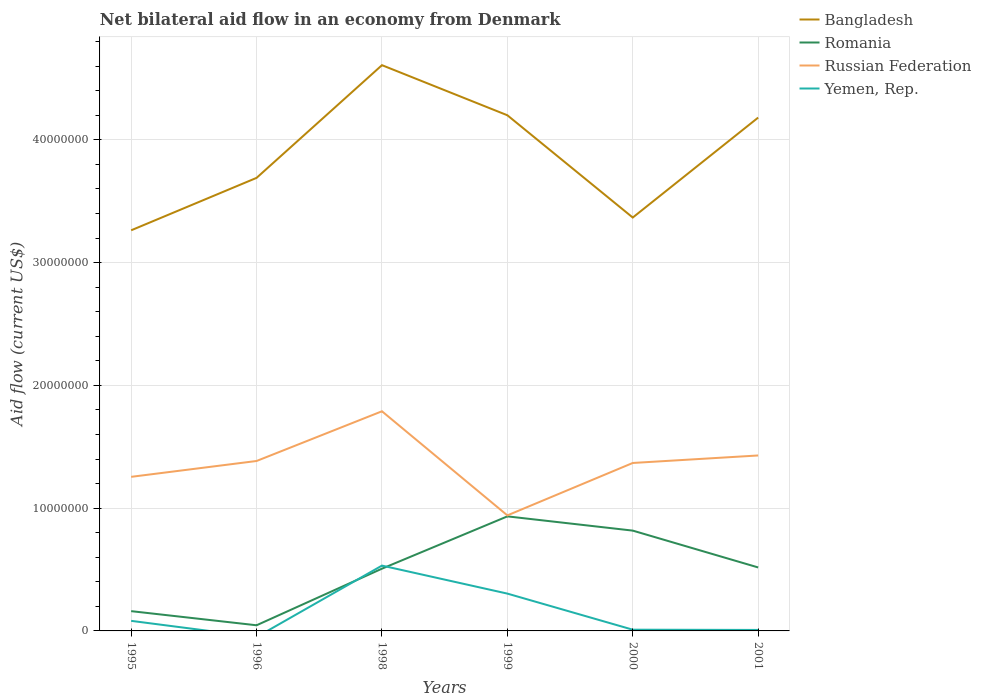How many different coloured lines are there?
Provide a succinct answer. 4. Across all years, what is the maximum net bilateral aid flow in Russian Federation?
Ensure brevity in your answer.  9.41e+06. What is the total net bilateral aid flow in Romania in the graph?
Your answer should be very brief. -4.71e+06. What is the difference between the highest and the second highest net bilateral aid flow in Romania?
Give a very brief answer. 8.87e+06. How many lines are there?
Your response must be concise. 4. How many years are there in the graph?
Your answer should be compact. 6. What is the difference between two consecutive major ticks on the Y-axis?
Provide a succinct answer. 1.00e+07. Are the values on the major ticks of Y-axis written in scientific E-notation?
Offer a very short reply. No. Does the graph contain any zero values?
Offer a very short reply. Yes. Does the graph contain grids?
Offer a very short reply. Yes. Where does the legend appear in the graph?
Keep it short and to the point. Top right. How many legend labels are there?
Your answer should be very brief. 4. How are the legend labels stacked?
Ensure brevity in your answer.  Vertical. What is the title of the graph?
Your answer should be very brief. Net bilateral aid flow in an economy from Denmark. What is the label or title of the Y-axis?
Keep it short and to the point. Aid flow (current US$). What is the Aid flow (current US$) of Bangladesh in 1995?
Your answer should be compact. 3.26e+07. What is the Aid flow (current US$) of Romania in 1995?
Make the answer very short. 1.61e+06. What is the Aid flow (current US$) in Russian Federation in 1995?
Ensure brevity in your answer.  1.26e+07. What is the Aid flow (current US$) of Yemen, Rep. in 1995?
Give a very brief answer. 8.20e+05. What is the Aid flow (current US$) of Bangladesh in 1996?
Keep it short and to the point. 3.69e+07. What is the Aid flow (current US$) in Romania in 1996?
Offer a terse response. 4.60e+05. What is the Aid flow (current US$) of Russian Federation in 1996?
Your answer should be very brief. 1.38e+07. What is the Aid flow (current US$) of Yemen, Rep. in 1996?
Offer a terse response. 0. What is the Aid flow (current US$) of Bangladesh in 1998?
Make the answer very short. 4.61e+07. What is the Aid flow (current US$) of Romania in 1998?
Offer a very short reply. 5.07e+06. What is the Aid flow (current US$) of Russian Federation in 1998?
Make the answer very short. 1.79e+07. What is the Aid flow (current US$) in Yemen, Rep. in 1998?
Your answer should be compact. 5.32e+06. What is the Aid flow (current US$) of Bangladesh in 1999?
Ensure brevity in your answer.  4.20e+07. What is the Aid flow (current US$) in Romania in 1999?
Ensure brevity in your answer.  9.33e+06. What is the Aid flow (current US$) of Russian Federation in 1999?
Provide a succinct answer. 9.41e+06. What is the Aid flow (current US$) in Yemen, Rep. in 1999?
Provide a short and direct response. 3.04e+06. What is the Aid flow (current US$) in Bangladesh in 2000?
Your answer should be very brief. 3.37e+07. What is the Aid flow (current US$) in Romania in 2000?
Your answer should be compact. 8.17e+06. What is the Aid flow (current US$) of Russian Federation in 2000?
Provide a succinct answer. 1.37e+07. What is the Aid flow (current US$) of Yemen, Rep. in 2000?
Provide a short and direct response. 1.00e+05. What is the Aid flow (current US$) in Bangladesh in 2001?
Give a very brief answer. 4.18e+07. What is the Aid flow (current US$) of Romania in 2001?
Provide a short and direct response. 5.17e+06. What is the Aid flow (current US$) in Russian Federation in 2001?
Your answer should be very brief. 1.43e+07. Across all years, what is the maximum Aid flow (current US$) of Bangladesh?
Your answer should be compact. 4.61e+07. Across all years, what is the maximum Aid flow (current US$) in Romania?
Offer a very short reply. 9.33e+06. Across all years, what is the maximum Aid flow (current US$) of Russian Federation?
Ensure brevity in your answer.  1.79e+07. Across all years, what is the maximum Aid flow (current US$) of Yemen, Rep.?
Offer a very short reply. 5.32e+06. Across all years, what is the minimum Aid flow (current US$) of Bangladesh?
Your answer should be compact. 3.26e+07. Across all years, what is the minimum Aid flow (current US$) in Russian Federation?
Your response must be concise. 9.41e+06. What is the total Aid flow (current US$) of Bangladesh in the graph?
Provide a short and direct response. 2.33e+08. What is the total Aid flow (current US$) of Romania in the graph?
Your response must be concise. 2.98e+07. What is the total Aid flow (current US$) in Russian Federation in the graph?
Your answer should be very brief. 8.17e+07. What is the total Aid flow (current US$) in Yemen, Rep. in the graph?
Your answer should be compact. 9.36e+06. What is the difference between the Aid flow (current US$) in Bangladesh in 1995 and that in 1996?
Keep it short and to the point. -4.27e+06. What is the difference between the Aid flow (current US$) of Romania in 1995 and that in 1996?
Your response must be concise. 1.15e+06. What is the difference between the Aid flow (current US$) of Russian Federation in 1995 and that in 1996?
Keep it short and to the point. -1.29e+06. What is the difference between the Aid flow (current US$) in Bangladesh in 1995 and that in 1998?
Offer a terse response. -1.34e+07. What is the difference between the Aid flow (current US$) of Romania in 1995 and that in 1998?
Provide a short and direct response. -3.46e+06. What is the difference between the Aid flow (current US$) of Russian Federation in 1995 and that in 1998?
Make the answer very short. -5.34e+06. What is the difference between the Aid flow (current US$) of Yemen, Rep. in 1995 and that in 1998?
Make the answer very short. -4.50e+06. What is the difference between the Aid flow (current US$) of Bangladesh in 1995 and that in 1999?
Give a very brief answer. -9.37e+06. What is the difference between the Aid flow (current US$) of Romania in 1995 and that in 1999?
Provide a succinct answer. -7.72e+06. What is the difference between the Aid flow (current US$) in Russian Federation in 1995 and that in 1999?
Keep it short and to the point. 3.14e+06. What is the difference between the Aid flow (current US$) of Yemen, Rep. in 1995 and that in 1999?
Offer a terse response. -2.22e+06. What is the difference between the Aid flow (current US$) of Bangladesh in 1995 and that in 2000?
Ensure brevity in your answer.  -1.04e+06. What is the difference between the Aid flow (current US$) of Romania in 1995 and that in 2000?
Your response must be concise. -6.56e+06. What is the difference between the Aid flow (current US$) of Russian Federation in 1995 and that in 2000?
Give a very brief answer. -1.13e+06. What is the difference between the Aid flow (current US$) in Yemen, Rep. in 1995 and that in 2000?
Your answer should be very brief. 7.20e+05. What is the difference between the Aid flow (current US$) in Bangladesh in 1995 and that in 2001?
Your response must be concise. -9.18e+06. What is the difference between the Aid flow (current US$) of Romania in 1995 and that in 2001?
Give a very brief answer. -3.56e+06. What is the difference between the Aid flow (current US$) in Russian Federation in 1995 and that in 2001?
Make the answer very short. -1.74e+06. What is the difference between the Aid flow (current US$) in Yemen, Rep. in 1995 and that in 2001?
Offer a very short reply. 7.40e+05. What is the difference between the Aid flow (current US$) of Bangladesh in 1996 and that in 1998?
Give a very brief answer. -9.18e+06. What is the difference between the Aid flow (current US$) in Romania in 1996 and that in 1998?
Your response must be concise. -4.61e+06. What is the difference between the Aid flow (current US$) of Russian Federation in 1996 and that in 1998?
Your response must be concise. -4.05e+06. What is the difference between the Aid flow (current US$) in Bangladesh in 1996 and that in 1999?
Keep it short and to the point. -5.10e+06. What is the difference between the Aid flow (current US$) of Romania in 1996 and that in 1999?
Provide a short and direct response. -8.87e+06. What is the difference between the Aid flow (current US$) of Russian Federation in 1996 and that in 1999?
Keep it short and to the point. 4.43e+06. What is the difference between the Aid flow (current US$) of Bangladesh in 1996 and that in 2000?
Make the answer very short. 3.23e+06. What is the difference between the Aid flow (current US$) in Romania in 1996 and that in 2000?
Keep it short and to the point. -7.71e+06. What is the difference between the Aid flow (current US$) of Russian Federation in 1996 and that in 2000?
Give a very brief answer. 1.60e+05. What is the difference between the Aid flow (current US$) in Bangladesh in 1996 and that in 2001?
Give a very brief answer. -4.91e+06. What is the difference between the Aid flow (current US$) of Romania in 1996 and that in 2001?
Make the answer very short. -4.71e+06. What is the difference between the Aid flow (current US$) of Russian Federation in 1996 and that in 2001?
Offer a very short reply. -4.50e+05. What is the difference between the Aid flow (current US$) in Bangladesh in 1998 and that in 1999?
Ensure brevity in your answer.  4.08e+06. What is the difference between the Aid flow (current US$) in Romania in 1998 and that in 1999?
Provide a short and direct response. -4.26e+06. What is the difference between the Aid flow (current US$) of Russian Federation in 1998 and that in 1999?
Offer a terse response. 8.48e+06. What is the difference between the Aid flow (current US$) in Yemen, Rep. in 1998 and that in 1999?
Make the answer very short. 2.28e+06. What is the difference between the Aid flow (current US$) of Bangladesh in 1998 and that in 2000?
Keep it short and to the point. 1.24e+07. What is the difference between the Aid flow (current US$) in Romania in 1998 and that in 2000?
Provide a short and direct response. -3.10e+06. What is the difference between the Aid flow (current US$) in Russian Federation in 1998 and that in 2000?
Provide a succinct answer. 4.21e+06. What is the difference between the Aid flow (current US$) in Yemen, Rep. in 1998 and that in 2000?
Your answer should be compact. 5.22e+06. What is the difference between the Aid flow (current US$) of Bangladesh in 1998 and that in 2001?
Your response must be concise. 4.27e+06. What is the difference between the Aid flow (current US$) of Romania in 1998 and that in 2001?
Your response must be concise. -1.00e+05. What is the difference between the Aid flow (current US$) in Russian Federation in 1998 and that in 2001?
Provide a succinct answer. 3.60e+06. What is the difference between the Aid flow (current US$) of Yemen, Rep. in 1998 and that in 2001?
Provide a succinct answer. 5.24e+06. What is the difference between the Aid flow (current US$) in Bangladesh in 1999 and that in 2000?
Provide a short and direct response. 8.33e+06. What is the difference between the Aid flow (current US$) in Romania in 1999 and that in 2000?
Provide a short and direct response. 1.16e+06. What is the difference between the Aid flow (current US$) of Russian Federation in 1999 and that in 2000?
Your answer should be compact. -4.27e+06. What is the difference between the Aid flow (current US$) of Yemen, Rep. in 1999 and that in 2000?
Make the answer very short. 2.94e+06. What is the difference between the Aid flow (current US$) in Romania in 1999 and that in 2001?
Your response must be concise. 4.16e+06. What is the difference between the Aid flow (current US$) in Russian Federation in 1999 and that in 2001?
Keep it short and to the point. -4.88e+06. What is the difference between the Aid flow (current US$) in Yemen, Rep. in 1999 and that in 2001?
Your answer should be very brief. 2.96e+06. What is the difference between the Aid flow (current US$) of Bangladesh in 2000 and that in 2001?
Keep it short and to the point. -8.14e+06. What is the difference between the Aid flow (current US$) of Russian Federation in 2000 and that in 2001?
Offer a terse response. -6.10e+05. What is the difference between the Aid flow (current US$) of Bangladesh in 1995 and the Aid flow (current US$) of Romania in 1996?
Your response must be concise. 3.22e+07. What is the difference between the Aid flow (current US$) of Bangladesh in 1995 and the Aid flow (current US$) of Russian Federation in 1996?
Your response must be concise. 1.88e+07. What is the difference between the Aid flow (current US$) in Romania in 1995 and the Aid flow (current US$) in Russian Federation in 1996?
Offer a terse response. -1.22e+07. What is the difference between the Aid flow (current US$) in Bangladesh in 1995 and the Aid flow (current US$) in Romania in 1998?
Keep it short and to the point. 2.76e+07. What is the difference between the Aid flow (current US$) of Bangladesh in 1995 and the Aid flow (current US$) of Russian Federation in 1998?
Offer a terse response. 1.47e+07. What is the difference between the Aid flow (current US$) of Bangladesh in 1995 and the Aid flow (current US$) of Yemen, Rep. in 1998?
Provide a succinct answer. 2.73e+07. What is the difference between the Aid flow (current US$) of Romania in 1995 and the Aid flow (current US$) of Russian Federation in 1998?
Offer a terse response. -1.63e+07. What is the difference between the Aid flow (current US$) of Romania in 1995 and the Aid flow (current US$) of Yemen, Rep. in 1998?
Offer a terse response. -3.71e+06. What is the difference between the Aid flow (current US$) in Russian Federation in 1995 and the Aid flow (current US$) in Yemen, Rep. in 1998?
Provide a succinct answer. 7.23e+06. What is the difference between the Aid flow (current US$) in Bangladesh in 1995 and the Aid flow (current US$) in Romania in 1999?
Provide a short and direct response. 2.33e+07. What is the difference between the Aid flow (current US$) in Bangladesh in 1995 and the Aid flow (current US$) in Russian Federation in 1999?
Offer a terse response. 2.32e+07. What is the difference between the Aid flow (current US$) of Bangladesh in 1995 and the Aid flow (current US$) of Yemen, Rep. in 1999?
Provide a short and direct response. 2.96e+07. What is the difference between the Aid flow (current US$) in Romania in 1995 and the Aid flow (current US$) in Russian Federation in 1999?
Your response must be concise. -7.80e+06. What is the difference between the Aid flow (current US$) of Romania in 1995 and the Aid flow (current US$) of Yemen, Rep. in 1999?
Give a very brief answer. -1.43e+06. What is the difference between the Aid flow (current US$) in Russian Federation in 1995 and the Aid flow (current US$) in Yemen, Rep. in 1999?
Provide a succinct answer. 9.51e+06. What is the difference between the Aid flow (current US$) in Bangladesh in 1995 and the Aid flow (current US$) in Romania in 2000?
Provide a short and direct response. 2.45e+07. What is the difference between the Aid flow (current US$) of Bangladesh in 1995 and the Aid flow (current US$) of Russian Federation in 2000?
Provide a short and direct response. 1.90e+07. What is the difference between the Aid flow (current US$) in Bangladesh in 1995 and the Aid flow (current US$) in Yemen, Rep. in 2000?
Keep it short and to the point. 3.25e+07. What is the difference between the Aid flow (current US$) in Romania in 1995 and the Aid flow (current US$) in Russian Federation in 2000?
Offer a terse response. -1.21e+07. What is the difference between the Aid flow (current US$) in Romania in 1995 and the Aid flow (current US$) in Yemen, Rep. in 2000?
Make the answer very short. 1.51e+06. What is the difference between the Aid flow (current US$) in Russian Federation in 1995 and the Aid flow (current US$) in Yemen, Rep. in 2000?
Keep it short and to the point. 1.24e+07. What is the difference between the Aid flow (current US$) of Bangladesh in 1995 and the Aid flow (current US$) of Romania in 2001?
Make the answer very short. 2.75e+07. What is the difference between the Aid flow (current US$) of Bangladesh in 1995 and the Aid flow (current US$) of Russian Federation in 2001?
Ensure brevity in your answer.  1.83e+07. What is the difference between the Aid flow (current US$) of Bangladesh in 1995 and the Aid flow (current US$) of Yemen, Rep. in 2001?
Provide a succinct answer. 3.26e+07. What is the difference between the Aid flow (current US$) in Romania in 1995 and the Aid flow (current US$) in Russian Federation in 2001?
Your answer should be compact. -1.27e+07. What is the difference between the Aid flow (current US$) of Romania in 1995 and the Aid flow (current US$) of Yemen, Rep. in 2001?
Keep it short and to the point. 1.53e+06. What is the difference between the Aid flow (current US$) in Russian Federation in 1995 and the Aid flow (current US$) in Yemen, Rep. in 2001?
Provide a short and direct response. 1.25e+07. What is the difference between the Aid flow (current US$) of Bangladesh in 1996 and the Aid flow (current US$) of Romania in 1998?
Keep it short and to the point. 3.18e+07. What is the difference between the Aid flow (current US$) of Bangladesh in 1996 and the Aid flow (current US$) of Russian Federation in 1998?
Provide a short and direct response. 1.90e+07. What is the difference between the Aid flow (current US$) of Bangladesh in 1996 and the Aid flow (current US$) of Yemen, Rep. in 1998?
Provide a succinct answer. 3.16e+07. What is the difference between the Aid flow (current US$) in Romania in 1996 and the Aid flow (current US$) in Russian Federation in 1998?
Your response must be concise. -1.74e+07. What is the difference between the Aid flow (current US$) in Romania in 1996 and the Aid flow (current US$) in Yemen, Rep. in 1998?
Ensure brevity in your answer.  -4.86e+06. What is the difference between the Aid flow (current US$) in Russian Federation in 1996 and the Aid flow (current US$) in Yemen, Rep. in 1998?
Offer a terse response. 8.52e+06. What is the difference between the Aid flow (current US$) in Bangladesh in 1996 and the Aid flow (current US$) in Romania in 1999?
Give a very brief answer. 2.76e+07. What is the difference between the Aid flow (current US$) of Bangladesh in 1996 and the Aid flow (current US$) of Russian Federation in 1999?
Your answer should be compact. 2.75e+07. What is the difference between the Aid flow (current US$) of Bangladesh in 1996 and the Aid flow (current US$) of Yemen, Rep. in 1999?
Make the answer very short. 3.39e+07. What is the difference between the Aid flow (current US$) in Romania in 1996 and the Aid flow (current US$) in Russian Federation in 1999?
Provide a short and direct response. -8.95e+06. What is the difference between the Aid flow (current US$) in Romania in 1996 and the Aid flow (current US$) in Yemen, Rep. in 1999?
Your response must be concise. -2.58e+06. What is the difference between the Aid flow (current US$) of Russian Federation in 1996 and the Aid flow (current US$) of Yemen, Rep. in 1999?
Give a very brief answer. 1.08e+07. What is the difference between the Aid flow (current US$) of Bangladesh in 1996 and the Aid flow (current US$) of Romania in 2000?
Provide a short and direct response. 2.87e+07. What is the difference between the Aid flow (current US$) of Bangladesh in 1996 and the Aid flow (current US$) of Russian Federation in 2000?
Make the answer very short. 2.32e+07. What is the difference between the Aid flow (current US$) in Bangladesh in 1996 and the Aid flow (current US$) in Yemen, Rep. in 2000?
Keep it short and to the point. 3.68e+07. What is the difference between the Aid flow (current US$) of Romania in 1996 and the Aid flow (current US$) of Russian Federation in 2000?
Your answer should be compact. -1.32e+07. What is the difference between the Aid flow (current US$) of Russian Federation in 1996 and the Aid flow (current US$) of Yemen, Rep. in 2000?
Provide a short and direct response. 1.37e+07. What is the difference between the Aid flow (current US$) of Bangladesh in 1996 and the Aid flow (current US$) of Romania in 2001?
Your answer should be compact. 3.17e+07. What is the difference between the Aid flow (current US$) of Bangladesh in 1996 and the Aid flow (current US$) of Russian Federation in 2001?
Offer a very short reply. 2.26e+07. What is the difference between the Aid flow (current US$) in Bangladesh in 1996 and the Aid flow (current US$) in Yemen, Rep. in 2001?
Your answer should be compact. 3.68e+07. What is the difference between the Aid flow (current US$) in Romania in 1996 and the Aid flow (current US$) in Russian Federation in 2001?
Make the answer very short. -1.38e+07. What is the difference between the Aid flow (current US$) of Romania in 1996 and the Aid flow (current US$) of Yemen, Rep. in 2001?
Offer a terse response. 3.80e+05. What is the difference between the Aid flow (current US$) of Russian Federation in 1996 and the Aid flow (current US$) of Yemen, Rep. in 2001?
Keep it short and to the point. 1.38e+07. What is the difference between the Aid flow (current US$) in Bangladesh in 1998 and the Aid flow (current US$) in Romania in 1999?
Keep it short and to the point. 3.68e+07. What is the difference between the Aid flow (current US$) in Bangladesh in 1998 and the Aid flow (current US$) in Russian Federation in 1999?
Offer a very short reply. 3.67e+07. What is the difference between the Aid flow (current US$) of Bangladesh in 1998 and the Aid flow (current US$) of Yemen, Rep. in 1999?
Your answer should be compact. 4.30e+07. What is the difference between the Aid flow (current US$) of Romania in 1998 and the Aid flow (current US$) of Russian Federation in 1999?
Offer a very short reply. -4.34e+06. What is the difference between the Aid flow (current US$) in Romania in 1998 and the Aid flow (current US$) in Yemen, Rep. in 1999?
Offer a terse response. 2.03e+06. What is the difference between the Aid flow (current US$) of Russian Federation in 1998 and the Aid flow (current US$) of Yemen, Rep. in 1999?
Your answer should be compact. 1.48e+07. What is the difference between the Aid flow (current US$) of Bangladesh in 1998 and the Aid flow (current US$) of Romania in 2000?
Provide a succinct answer. 3.79e+07. What is the difference between the Aid flow (current US$) of Bangladesh in 1998 and the Aid flow (current US$) of Russian Federation in 2000?
Give a very brief answer. 3.24e+07. What is the difference between the Aid flow (current US$) in Bangladesh in 1998 and the Aid flow (current US$) in Yemen, Rep. in 2000?
Provide a short and direct response. 4.60e+07. What is the difference between the Aid flow (current US$) of Romania in 1998 and the Aid flow (current US$) of Russian Federation in 2000?
Keep it short and to the point. -8.61e+06. What is the difference between the Aid flow (current US$) in Romania in 1998 and the Aid flow (current US$) in Yemen, Rep. in 2000?
Your answer should be compact. 4.97e+06. What is the difference between the Aid flow (current US$) of Russian Federation in 1998 and the Aid flow (current US$) of Yemen, Rep. in 2000?
Make the answer very short. 1.78e+07. What is the difference between the Aid flow (current US$) of Bangladesh in 1998 and the Aid flow (current US$) of Romania in 2001?
Ensure brevity in your answer.  4.09e+07. What is the difference between the Aid flow (current US$) in Bangladesh in 1998 and the Aid flow (current US$) in Russian Federation in 2001?
Provide a short and direct response. 3.18e+07. What is the difference between the Aid flow (current US$) of Bangladesh in 1998 and the Aid flow (current US$) of Yemen, Rep. in 2001?
Ensure brevity in your answer.  4.60e+07. What is the difference between the Aid flow (current US$) in Romania in 1998 and the Aid flow (current US$) in Russian Federation in 2001?
Offer a terse response. -9.22e+06. What is the difference between the Aid flow (current US$) of Romania in 1998 and the Aid flow (current US$) of Yemen, Rep. in 2001?
Keep it short and to the point. 4.99e+06. What is the difference between the Aid flow (current US$) in Russian Federation in 1998 and the Aid flow (current US$) in Yemen, Rep. in 2001?
Your response must be concise. 1.78e+07. What is the difference between the Aid flow (current US$) in Bangladesh in 1999 and the Aid flow (current US$) in Romania in 2000?
Your answer should be compact. 3.38e+07. What is the difference between the Aid flow (current US$) of Bangladesh in 1999 and the Aid flow (current US$) of Russian Federation in 2000?
Provide a succinct answer. 2.83e+07. What is the difference between the Aid flow (current US$) in Bangladesh in 1999 and the Aid flow (current US$) in Yemen, Rep. in 2000?
Offer a very short reply. 4.19e+07. What is the difference between the Aid flow (current US$) in Romania in 1999 and the Aid flow (current US$) in Russian Federation in 2000?
Your response must be concise. -4.35e+06. What is the difference between the Aid flow (current US$) of Romania in 1999 and the Aid flow (current US$) of Yemen, Rep. in 2000?
Offer a very short reply. 9.23e+06. What is the difference between the Aid flow (current US$) in Russian Federation in 1999 and the Aid flow (current US$) in Yemen, Rep. in 2000?
Ensure brevity in your answer.  9.31e+06. What is the difference between the Aid flow (current US$) in Bangladesh in 1999 and the Aid flow (current US$) in Romania in 2001?
Offer a very short reply. 3.68e+07. What is the difference between the Aid flow (current US$) in Bangladesh in 1999 and the Aid flow (current US$) in Russian Federation in 2001?
Give a very brief answer. 2.77e+07. What is the difference between the Aid flow (current US$) in Bangladesh in 1999 and the Aid flow (current US$) in Yemen, Rep. in 2001?
Ensure brevity in your answer.  4.19e+07. What is the difference between the Aid flow (current US$) in Romania in 1999 and the Aid flow (current US$) in Russian Federation in 2001?
Ensure brevity in your answer.  -4.96e+06. What is the difference between the Aid flow (current US$) of Romania in 1999 and the Aid flow (current US$) of Yemen, Rep. in 2001?
Give a very brief answer. 9.25e+06. What is the difference between the Aid flow (current US$) of Russian Federation in 1999 and the Aid flow (current US$) of Yemen, Rep. in 2001?
Your answer should be compact. 9.33e+06. What is the difference between the Aid flow (current US$) in Bangladesh in 2000 and the Aid flow (current US$) in Romania in 2001?
Offer a very short reply. 2.85e+07. What is the difference between the Aid flow (current US$) in Bangladesh in 2000 and the Aid flow (current US$) in Russian Federation in 2001?
Provide a succinct answer. 1.94e+07. What is the difference between the Aid flow (current US$) in Bangladesh in 2000 and the Aid flow (current US$) in Yemen, Rep. in 2001?
Give a very brief answer. 3.36e+07. What is the difference between the Aid flow (current US$) of Romania in 2000 and the Aid flow (current US$) of Russian Federation in 2001?
Ensure brevity in your answer.  -6.12e+06. What is the difference between the Aid flow (current US$) in Romania in 2000 and the Aid flow (current US$) in Yemen, Rep. in 2001?
Offer a very short reply. 8.09e+06. What is the difference between the Aid flow (current US$) in Russian Federation in 2000 and the Aid flow (current US$) in Yemen, Rep. in 2001?
Ensure brevity in your answer.  1.36e+07. What is the average Aid flow (current US$) of Bangladesh per year?
Ensure brevity in your answer.  3.88e+07. What is the average Aid flow (current US$) of Romania per year?
Keep it short and to the point. 4.97e+06. What is the average Aid flow (current US$) in Russian Federation per year?
Your answer should be compact. 1.36e+07. What is the average Aid flow (current US$) of Yemen, Rep. per year?
Provide a succinct answer. 1.56e+06. In the year 1995, what is the difference between the Aid flow (current US$) in Bangladesh and Aid flow (current US$) in Romania?
Provide a short and direct response. 3.10e+07. In the year 1995, what is the difference between the Aid flow (current US$) of Bangladesh and Aid flow (current US$) of Russian Federation?
Offer a terse response. 2.01e+07. In the year 1995, what is the difference between the Aid flow (current US$) of Bangladesh and Aid flow (current US$) of Yemen, Rep.?
Your answer should be very brief. 3.18e+07. In the year 1995, what is the difference between the Aid flow (current US$) in Romania and Aid flow (current US$) in Russian Federation?
Give a very brief answer. -1.09e+07. In the year 1995, what is the difference between the Aid flow (current US$) of Romania and Aid flow (current US$) of Yemen, Rep.?
Ensure brevity in your answer.  7.90e+05. In the year 1995, what is the difference between the Aid flow (current US$) in Russian Federation and Aid flow (current US$) in Yemen, Rep.?
Your answer should be compact. 1.17e+07. In the year 1996, what is the difference between the Aid flow (current US$) of Bangladesh and Aid flow (current US$) of Romania?
Your answer should be compact. 3.64e+07. In the year 1996, what is the difference between the Aid flow (current US$) in Bangladesh and Aid flow (current US$) in Russian Federation?
Your answer should be compact. 2.31e+07. In the year 1996, what is the difference between the Aid flow (current US$) in Romania and Aid flow (current US$) in Russian Federation?
Your response must be concise. -1.34e+07. In the year 1998, what is the difference between the Aid flow (current US$) of Bangladesh and Aid flow (current US$) of Romania?
Keep it short and to the point. 4.10e+07. In the year 1998, what is the difference between the Aid flow (current US$) of Bangladesh and Aid flow (current US$) of Russian Federation?
Offer a very short reply. 2.82e+07. In the year 1998, what is the difference between the Aid flow (current US$) in Bangladesh and Aid flow (current US$) in Yemen, Rep.?
Provide a short and direct response. 4.08e+07. In the year 1998, what is the difference between the Aid flow (current US$) in Romania and Aid flow (current US$) in Russian Federation?
Offer a terse response. -1.28e+07. In the year 1998, what is the difference between the Aid flow (current US$) in Romania and Aid flow (current US$) in Yemen, Rep.?
Provide a succinct answer. -2.50e+05. In the year 1998, what is the difference between the Aid flow (current US$) in Russian Federation and Aid flow (current US$) in Yemen, Rep.?
Your response must be concise. 1.26e+07. In the year 1999, what is the difference between the Aid flow (current US$) in Bangladesh and Aid flow (current US$) in Romania?
Provide a succinct answer. 3.27e+07. In the year 1999, what is the difference between the Aid flow (current US$) of Bangladesh and Aid flow (current US$) of Russian Federation?
Your response must be concise. 3.26e+07. In the year 1999, what is the difference between the Aid flow (current US$) of Bangladesh and Aid flow (current US$) of Yemen, Rep.?
Offer a terse response. 3.90e+07. In the year 1999, what is the difference between the Aid flow (current US$) of Romania and Aid flow (current US$) of Yemen, Rep.?
Offer a very short reply. 6.29e+06. In the year 1999, what is the difference between the Aid flow (current US$) in Russian Federation and Aid flow (current US$) in Yemen, Rep.?
Offer a very short reply. 6.37e+06. In the year 2000, what is the difference between the Aid flow (current US$) of Bangladesh and Aid flow (current US$) of Romania?
Give a very brief answer. 2.55e+07. In the year 2000, what is the difference between the Aid flow (current US$) in Bangladesh and Aid flow (current US$) in Russian Federation?
Offer a terse response. 2.00e+07. In the year 2000, what is the difference between the Aid flow (current US$) of Bangladesh and Aid flow (current US$) of Yemen, Rep.?
Ensure brevity in your answer.  3.36e+07. In the year 2000, what is the difference between the Aid flow (current US$) in Romania and Aid flow (current US$) in Russian Federation?
Ensure brevity in your answer.  -5.51e+06. In the year 2000, what is the difference between the Aid flow (current US$) of Romania and Aid flow (current US$) of Yemen, Rep.?
Provide a succinct answer. 8.07e+06. In the year 2000, what is the difference between the Aid flow (current US$) of Russian Federation and Aid flow (current US$) of Yemen, Rep.?
Your answer should be very brief. 1.36e+07. In the year 2001, what is the difference between the Aid flow (current US$) in Bangladesh and Aid flow (current US$) in Romania?
Offer a terse response. 3.66e+07. In the year 2001, what is the difference between the Aid flow (current US$) of Bangladesh and Aid flow (current US$) of Russian Federation?
Provide a short and direct response. 2.75e+07. In the year 2001, what is the difference between the Aid flow (current US$) in Bangladesh and Aid flow (current US$) in Yemen, Rep.?
Give a very brief answer. 4.17e+07. In the year 2001, what is the difference between the Aid flow (current US$) of Romania and Aid flow (current US$) of Russian Federation?
Offer a very short reply. -9.12e+06. In the year 2001, what is the difference between the Aid flow (current US$) in Romania and Aid flow (current US$) in Yemen, Rep.?
Keep it short and to the point. 5.09e+06. In the year 2001, what is the difference between the Aid flow (current US$) of Russian Federation and Aid flow (current US$) of Yemen, Rep.?
Offer a terse response. 1.42e+07. What is the ratio of the Aid flow (current US$) of Bangladesh in 1995 to that in 1996?
Keep it short and to the point. 0.88. What is the ratio of the Aid flow (current US$) of Russian Federation in 1995 to that in 1996?
Offer a terse response. 0.91. What is the ratio of the Aid flow (current US$) of Bangladesh in 1995 to that in 1998?
Your response must be concise. 0.71. What is the ratio of the Aid flow (current US$) in Romania in 1995 to that in 1998?
Provide a short and direct response. 0.32. What is the ratio of the Aid flow (current US$) in Russian Federation in 1995 to that in 1998?
Provide a short and direct response. 0.7. What is the ratio of the Aid flow (current US$) of Yemen, Rep. in 1995 to that in 1998?
Your answer should be compact. 0.15. What is the ratio of the Aid flow (current US$) of Bangladesh in 1995 to that in 1999?
Your response must be concise. 0.78. What is the ratio of the Aid flow (current US$) of Romania in 1995 to that in 1999?
Provide a succinct answer. 0.17. What is the ratio of the Aid flow (current US$) in Russian Federation in 1995 to that in 1999?
Make the answer very short. 1.33. What is the ratio of the Aid flow (current US$) of Yemen, Rep. in 1995 to that in 1999?
Keep it short and to the point. 0.27. What is the ratio of the Aid flow (current US$) of Bangladesh in 1995 to that in 2000?
Offer a terse response. 0.97. What is the ratio of the Aid flow (current US$) of Romania in 1995 to that in 2000?
Your response must be concise. 0.2. What is the ratio of the Aid flow (current US$) in Russian Federation in 1995 to that in 2000?
Keep it short and to the point. 0.92. What is the ratio of the Aid flow (current US$) in Yemen, Rep. in 1995 to that in 2000?
Your answer should be very brief. 8.2. What is the ratio of the Aid flow (current US$) in Bangladesh in 1995 to that in 2001?
Your answer should be very brief. 0.78. What is the ratio of the Aid flow (current US$) of Romania in 1995 to that in 2001?
Provide a short and direct response. 0.31. What is the ratio of the Aid flow (current US$) in Russian Federation in 1995 to that in 2001?
Provide a short and direct response. 0.88. What is the ratio of the Aid flow (current US$) of Yemen, Rep. in 1995 to that in 2001?
Provide a short and direct response. 10.25. What is the ratio of the Aid flow (current US$) of Bangladesh in 1996 to that in 1998?
Your answer should be compact. 0.8. What is the ratio of the Aid flow (current US$) of Romania in 1996 to that in 1998?
Give a very brief answer. 0.09. What is the ratio of the Aid flow (current US$) of Russian Federation in 1996 to that in 1998?
Provide a succinct answer. 0.77. What is the ratio of the Aid flow (current US$) in Bangladesh in 1996 to that in 1999?
Make the answer very short. 0.88. What is the ratio of the Aid flow (current US$) in Romania in 1996 to that in 1999?
Your answer should be compact. 0.05. What is the ratio of the Aid flow (current US$) in Russian Federation in 1996 to that in 1999?
Offer a very short reply. 1.47. What is the ratio of the Aid flow (current US$) in Bangladesh in 1996 to that in 2000?
Your response must be concise. 1.1. What is the ratio of the Aid flow (current US$) in Romania in 1996 to that in 2000?
Keep it short and to the point. 0.06. What is the ratio of the Aid flow (current US$) in Russian Federation in 1996 to that in 2000?
Your answer should be very brief. 1.01. What is the ratio of the Aid flow (current US$) in Bangladesh in 1996 to that in 2001?
Your answer should be compact. 0.88. What is the ratio of the Aid flow (current US$) of Romania in 1996 to that in 2001?
Your answer should be compact. 0.09. What is the ratio of the Aid flow (current US$) of Russian Federation in 1996 to that in 2001?
Your answer should be compact. 0.97. What is the ratio of the Aid flow (current US$) in Bangladesh in 1998 to that in 1999?
Your answer should be very brief. 1.1. What is the ratio of the Aid flow (current US$) of Romania in 1998 to that in 1999?
Make the answer very short. 0.54. What is the ratio of the Aid flow (current US$) of Russian Federation in 1998 to that in 1999?
Make the answer very short. 1.9. What is the ratio of the Aid flow (current US$) in Yemen, Rep. in 1998 to that in 1999?
Offer a very short reply. 1.75. What is the ratio of the Aid flow (current US$) of Bangladesh in 1998 to that in 2000?
Your answer should be very brief. 1.37. What is the ratio of the Aid flow (current US$) in Romania in 1998 to that in 2000?
Offer a terse response. 0.62. What is the ratio of the Aid flow (current US$) in Russian Federation in 1998 to that in 2000?
Keep it short and to the point. 1.31. What is the ratio of the Aid flow (current US$) of Yemen, Rep. in 1998 to that in 2000?
Your answer should be compact. 53.2. What is the ratio of the Aid flow (current US$) of Bangladesh in 1998 to that in 2001?
Keep it short and to the point. 1.1. What is the ratio of the Aid flow (current US$) of Romania in 1998 to that in 2001?
Make the answer very short. 0.98. What is the ratio of the Aid flow (current US$) in Russian Federation in 1998 to that in 2001?
Keep it short and to the point. 1.25. What is the ratio of the Aid flow (current US$) in Yemen, Rep. in 1998 to that in 2001?
Offer a very short reply. 66.5. What is the ratio of the Aid flow (current US$) in Bangladesh in 1999 to that in 2000?
Your response must be concise. 1.25. What is the ratio of the Aid flow (current US$) of Romania in 1999 to that in 2000?
Offer a very short reply. 1.14. What is the ratio of the Aid flow (current US$) of Russian Federation in 1999 to that in 2000?
Provide a short and direct response. 0.69. What is the ratio of the Aid flow (current US$) of Yemen, Rep. in 1999 to that in 2000?
Provide a short and direct response. 30.4. What is the ratio of the Aid flow (current US$) of Romania in 1999 to that in 2001?
Keep it short and to the point. 1.8. What is the ratio of the Aid flow (current US$) of Russian Federation in 1999 to that in 2001?
Provide a succinct answer. 0.66. What is the ratio of the Aid flow (current US$) in Bangladesh in 2000 to that in 2001?
Provide a short and direct response. 0.81. What is the ratio of the Aid flow (current US$) of Romania in 2000 to that in 2001?
Make the answer very short. 1.58. What is the ratio of the Aid flow (current US$) of Russian Federation in 2000 to that in 2001?
Keep it short and to the point. 0.96. What is the difference between the highest and the second highest Aid flow (current US$) of Bangladesh?
Give a very brief answer. 4.08e+06. What is the difference between the highest and the second highest Aid flow (current US$) in Romania?
Make the answer very short. 1.16e+06. What is the difference between the highest and the second highest Aid flow (current US$) in Russian Federation?
Give a very brief answer. 3.60e+06. What is the difference between the highest and the second highest Aid flow (current US$) of Yemen, Rep.?
Give a very brief answer. 2.28e+06. What is the difference between the highest and the lowest Aid flow (current US$) of Bangladesh?
Offer a very short reply. 1.34e+07. What is the difference between the highest and the lowest Aid flow (current US$) in Romania?
Give a very brief answer. 8.87e+06. What is the difference between the highest and the lowest Aid flow (current US$) of Russian Federation?
Provide a succinct answer. 8.48e+06. What is the difference between the highest and the lowest Aid flow (current US$) in Yemen, Rep.?
Offer a terse response. 5.32e+06. 